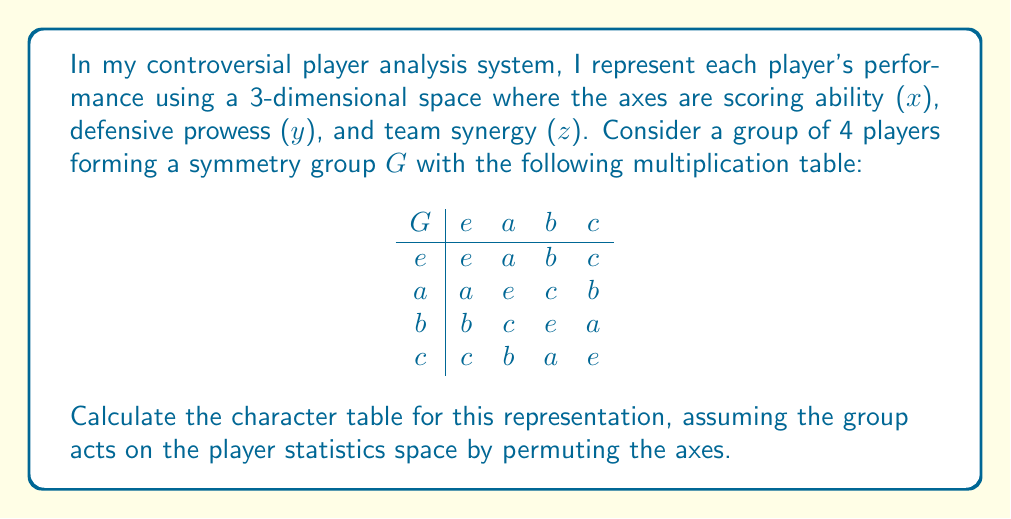Give your solution to this math problem. To calculate the character table for this representation, we'll follow these steps:

1) First, identify the group: This is the Klein four-group $V_4$, isomorphic to $C_2 \times C_2$.

2) Determine the conjugacy classes:
   Since $V_4$ is abelian, each element forms its own conjugacy class:
   $\{e\}, \{a\}, \{b\}, \{c\}$

3) Find the irreducible representations:
   For abelian groups, all irreducible representations are 1-dimensional and there are as many as there are conjugacy classes. So we have four 1-dimensional irreducible representations.

4) Construct the character table:
   - The trivial representation $\chi_1$ assigns 1 to all elements.
   - $\chi_2$, $\chi_3$, and $\chi_4$ assign 1 or -1 to each element, ensuring orthogonality.

   $$
   \begin{array}{c|cccc}
    V_4 & e & a & b & c \\
   \hline
   \chi_1 & 1 & 1 & 1 & 1 \\
   \chi_2 & 1 & 1 & -1 & -1 \\
   \chi_3 & 1 & -1 & 1 & -1 \\
   \chi_4 & 1 & -1 & -1 & 1
   \end{array}
   $$

5) Now, for our 3-dimensional representation $\rho$, we need to determine how each group element permutes the axes:
   - $e$: identity, fixes all axes. Character: 3
   - $a$: swaps $y$ and $z$, fixes $x$. Character: 1
   - $b$: swaps $x$ and $z$, fixes $y$. Character: 1
   - $c$: swaps $x$ and $y$, fixes $z$. Character: 1

6) Express $\rho$ in terms of irreducible representations:
   $\chi_\rho = (3,1,1,1) = \chi_1 + \chi_2 + \chi_3 + \chi_4$

Therefore, our 3-dimensional representation decomposes as the direct sum of all four 1-dimensional irreducible representations of $V_4$.
Answer: $$\chi_\rho = \chi_1 \oplus \chi_2 \oplus \chi_3 \oplus \chi_4$$ 